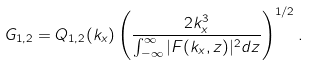Convert formula to latex. <formula><loc_0><loc_0><loc_500><loc_500>G _ { 1 , 2 } = Q _ { 1 , 2 } ( k _ { x } ) \left ( \frac { 2 k _ { x } ^ { 3 } } { \int _ { - \infty } ^ { \infty } | F ( k _ { x } , z ) | ^ { 2 } d z } \right ) ^ { 1 / 2 } .</formula> 